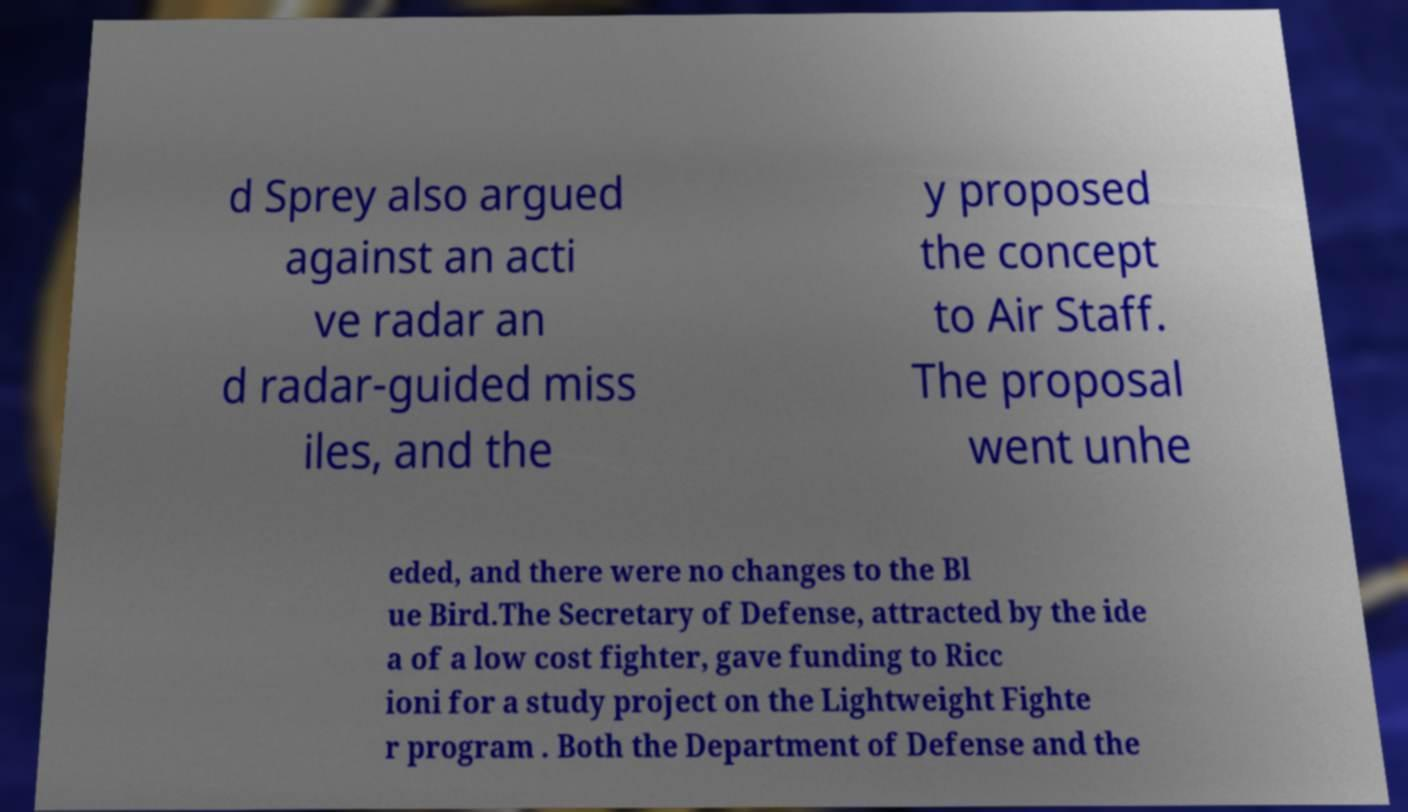What messages or text are displayed in this image? I need them in a readable, typed format. d Sprey also argued against an acti ve radar an d radar-guided miss iles, and the y proposed the concept to Air Staff. The proposal went unhe eded, and there were no changes to the Bl ue Bird.The Secretary of Defense, attracted by the ide a of a low cost fighter, gave funding to Ricc ioni for a study project on the Lightweight Fighte r program . Both the Department of Defense and the 